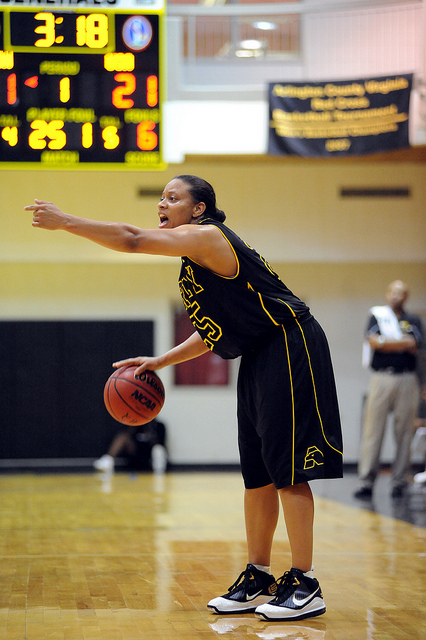Please extract the text content from this image. 3 18 1 21 25 5 CY 1 4 6 1 